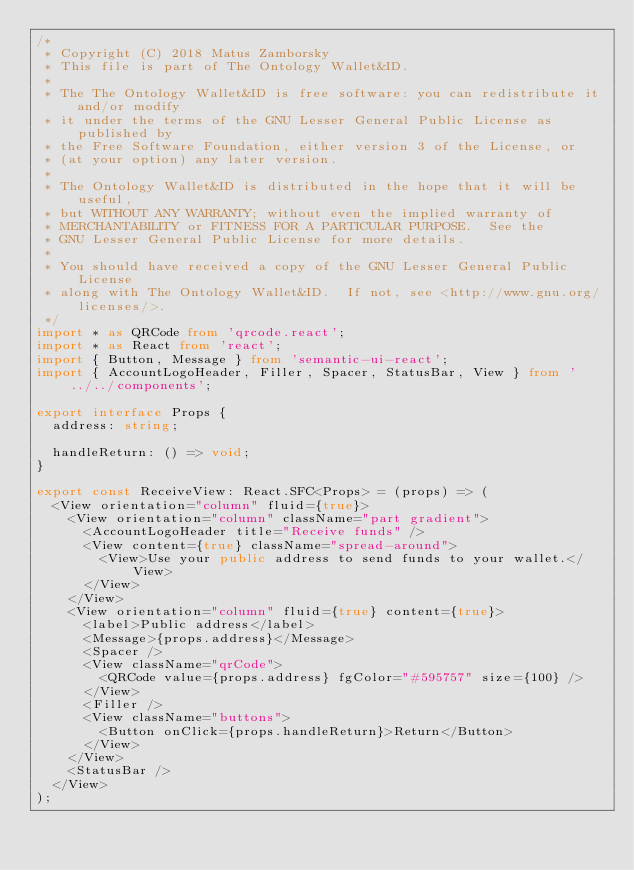<code> <loc_0><loc_0><loc_500><loc_500><_TypeScript_>/*
 * Copyright (C) 2018 Matus Zamborsky
 * This file is part of The Ontology Wallet&ID.
 *
 * The The Ontology Wallet&ID is free software: you can redistribute it and/or modify
 * it under the terms of the GNU Lesser General Public License as published by
 * the Free Software Foundation, either version 3 of the License, or
 * (at your option) any later version.
 *
 * The Ontology Wallet&ID is distributed in the hope that it will be useful,
 * but WITHOUT ANY WARRANTY; without even the implied warranty of
 * MERCHANTABILITY or FITNESS FOR A PARTICULAR PURPOSE.  See the
 * GNU Lesser General Public License for more details.
 *
 * You should have received a copy of the GNU Lesser General Public License
 * along with The Ontology Wallet&ID.  If not, see <http://www.gnu.org/licenses/>.
 */
import * as QRCode from 'qrcode.react';
import * as React from 'react';
import { Button, Message } from 'semantic-ui-react';
import { AccountLogoHeader, Filler, Spacer, StatusBar, View } from '../../components';

export interface Props {
  address: string;
  
  handleReturn: () => void;
}

export const ReceiveView: React.SFC<Props> = (props) => (
  <View orientation="column" fluid={true}>
    <View orientation="column" className="part gradient">
      <AccountLogoHeader title="Receive funds" />
      <View content={true} className="spread-around">
        <View>Use your public address to send funds to your wallet.</View>
      </View>
    </View>
    <View orientation="column" fluid={true} content={true}>
      <label>Public address</label>
      <Message>{props.address}</Message>
      <Spacer />
      <View className="qrCode">
        <QRCode value={props.address} fgColor="#595757" size={100} />
      </View>
      <Filler />
      <View className="buttons">
        <Button onClick={props.handleReturn}>Return</Button>
      </View>
    </View>
    <StatusBar />
  </View>
);
</code> 